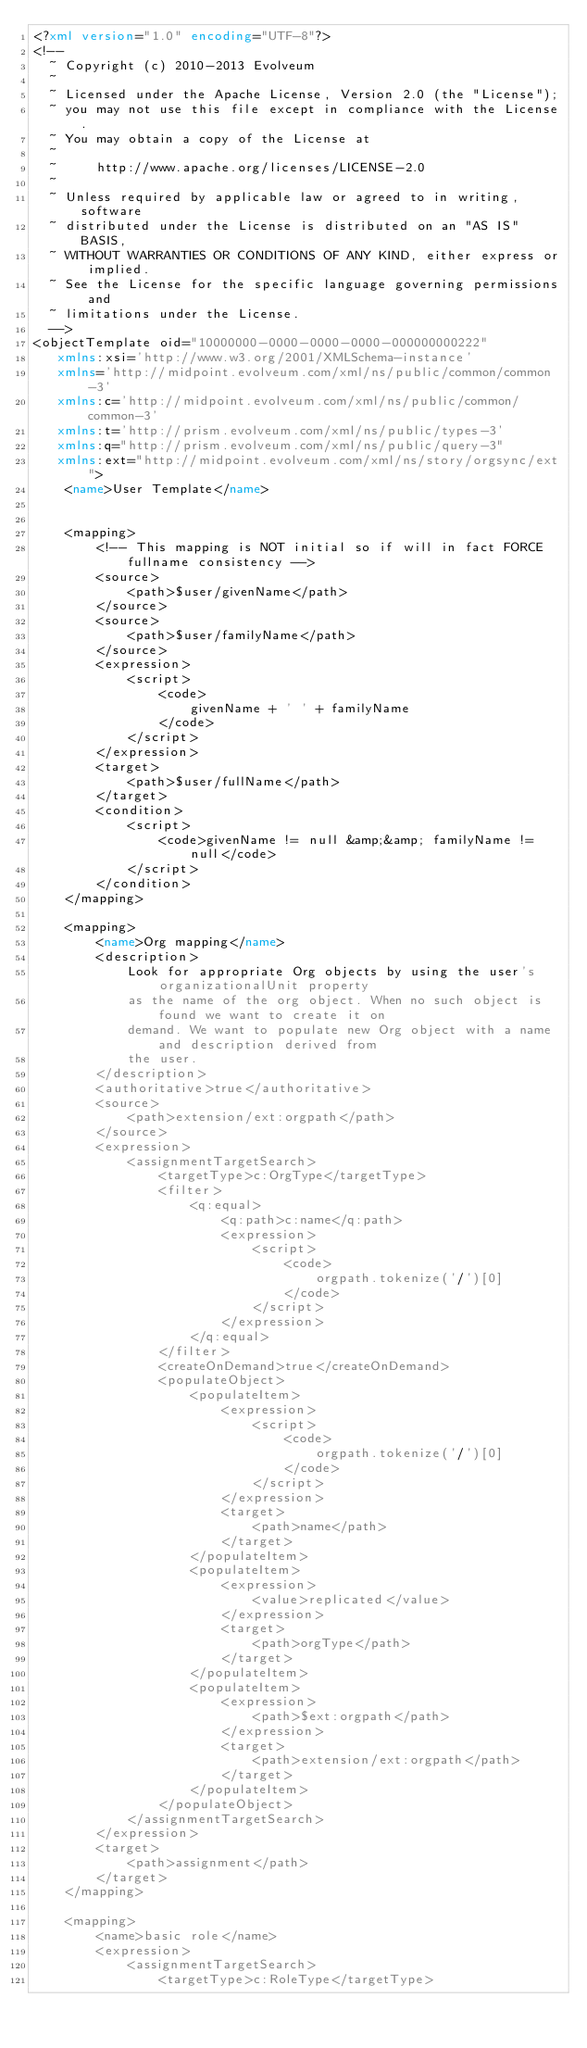Convert code to text. <code><loc_0><loc_0><loc_500><loc_500><_XML_><?xml version="1.0" encoding="UTF-8"?>
<!--
  ~ Copyright (c) 2010-2013 Evolveum
  ~
  ~ Licensed under the Apache License, Version 2.0 (the "License");
  ~ you may not use this file except in compliance with the License.
  ~ You may obtain a copy of the License at
  ~
  ~     http://www.apache.org/licenses/LICENSE-2.0
  ~
  ~ Unless required by applicable law or agreed to in writing, software
  ~ distributed under the License is distributed on an "AS IS" BASIS,
  ~ WITHOUT WARRANTIES OR CONDITIONS OF ANY KIND, either express or implied.
  ~ See the License for the specific language governing permissions and
  ~ limitations under the License.
  -->
<objectTemplate oid="10000000-0000-0000-0000-000000000222"
   xmlns:xsi='http://www.w3.org/2001/XMLSchema-instance'
   xmlns='http://midpoint.evolveum.com/xml/ns/public/common/common-3'
   xmlns:c='http://midpoint.evolveum.com/xml/ns/public/common/common-3'
   xmlns:t='http://prism.evolveum.com/xml/ns/public/types-3'
   xmlns:q="http://prism.evolveum.com/xml/ns/public/query-3"
   xmlns:ext="http://midpoint.evolveum.com/xml/ns/story/orgsync/ext">
    <name>User Template</name>
    
    
    <mapping>
    	<!-- This mapping is NOT initial so if will in fact FORCE fullname consistency -->
    	<source>
    		<path>$user/givenName</path>
    	</source>
    	<source>
    		<path>$user/familyName</path>
    	</source>
    	<expression>
			<script>
				<code>
					givenName + ' ' + familyName
				</code>
         	</script>
		</expression>
    	<target>
    		<path>$user/fullName</path>
    	</target>
    	<condition>
     		<script>
    			<code>givenName != null &amp;&amp; familyName != null</code>
    		</script>  
    	</condition>
    </mapping>
    
    <mapping>
    	<name>Org mapping</name>
    	<description>
    		Look for appropriate Org objects by using the user's organizationalUnit property
    		as the name of the org object. When no such object is found we want to create it on
    		demand. We want to populate new Org object with a name and description derived from
    		the user.
    	</description>
    	<authoritative>true</authoritative>
    	<source>
    		<path>extension/ext:orgpath</path>
    	</source>
    	<expression>
            <assignmentTargetSearch>
            	<targetType>c:OrgType</targetType>
        		<filter>
					<q:equal>
						<q:path>c:name</q:path>
						<expression>
							<script>
								<code>
									orgpath.tokenize('/')[0]
								</code>
							</script>
						</expression>
					</q:equal>
				</filter>
				<createOnDemand>true</createOnDemand>
				<populateObject>
					<populateItem>
						<expression>
							<script>
								<code>
									orgpath.tokenize('/')[0]
								</code>
							</script>
						</expression>
						<target>
							<path>name</path>
						</target>
					</populateItem>
					<populateItem>
						<expression>
							<value>replicated</value>
						</expression>
						<target>
							<path>orgType</path>
						</target>
					</populateItem>
					<populateItem>
						<expression>
							<path>$ext:orgpath</path>
						</expression>
						<target>
							<path>extension/ext:orgpath</path>
						</target>
					</populateItem>
				</populateObject>
            </assignmentTargetSearch>    	
    	</expression>
    	<target>
    		<path>assignment</path>
    	</target>
    </mapping>
    
    <mapping>
    	<name>basic role</name>
    	<expression>
            <assignmentTargetSearch>
            	<targetType>c:RoleType</targetType></code> 